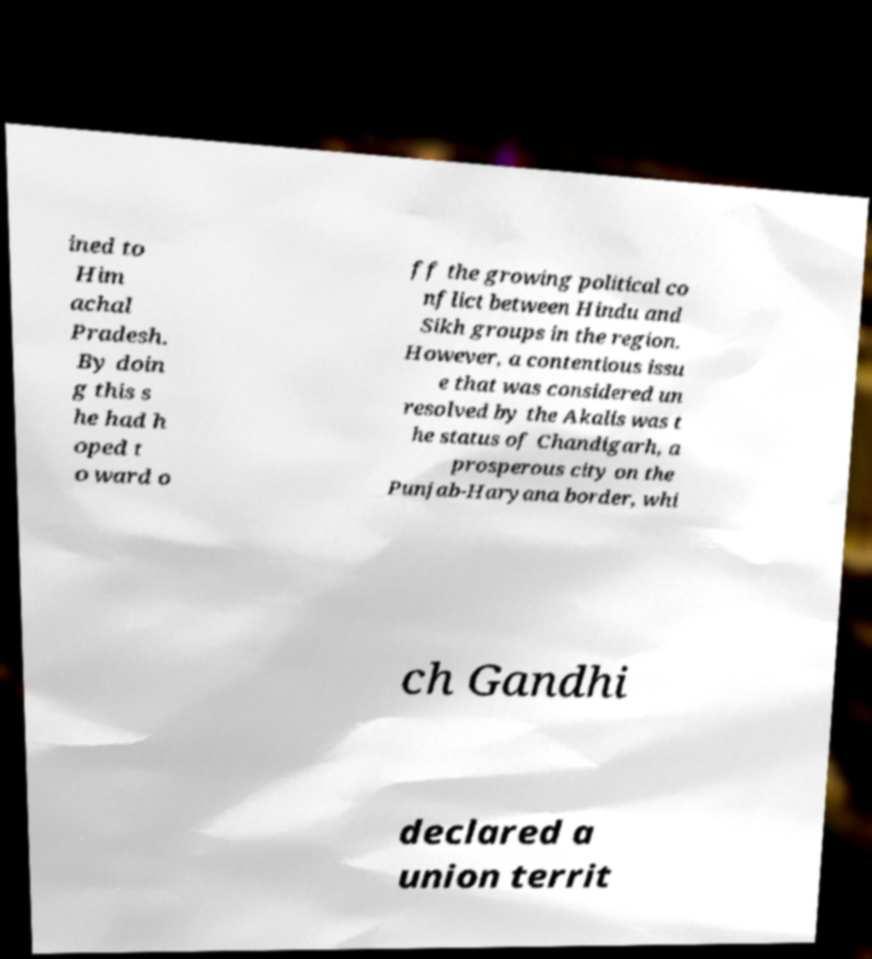Can you accurately transcribe the text from the provided image for me? ined to Him achal Pradesh. By doin g this s he had h oped t o ward o ff the growing political co nflict between Hindu and Sikh groups in the region. However, a contentious issu e that was considered un resolved by the Akalis was t he status of Chandigarh, a prosperous city on the Punjab-Haryana border, whi ch Gandhi declared a union territ 